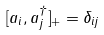Convert formula to latex. <formula><loc_0><loc_0><loc_500><loc_500>[ a _ { i } , a ^ { \dag } _ { j } ] _ { + } = \delta _ { i j }</formula> 